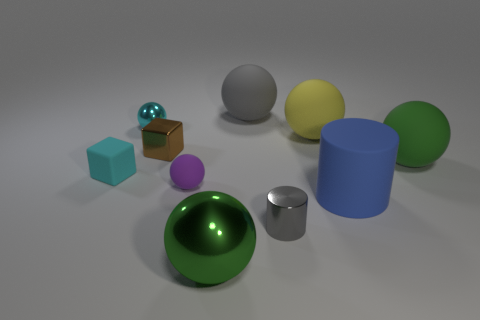What number of objects are matte balls on the right side of the big shiny ball or small red things?
Keep it short and to the point. 3. Is the color of the tiny rubber sphere the same as the metallic sphere that is behind the large green shiny thing?
Give a very brief answer. No. Is there a green rubber ball that has the same size as the purple sphere?
Offer a very short reply. No. What material is the tiny sphere in front of the large green sphere that is behind the green metallic sphere made of?
Make the answer very short. Rubber. What number of small rubber balls are the same color as the small matte block?
Your answer should be compact. 0. What shape is the cyan thing that is made of the same material as the tiny brown cube?
Offer a very short reply. Sphere. There is a metallic ball that is in front of the blue rubber object; how big is it?
Provide a short and direct response. Large. Is the number of cylinders that are behind the cyan metallic object the same as the number of small purple rubber balls that are on the right side of the yellow rubber object?
Give a very brief answer. Yes. What color is the metal sphere that is on the right side of the rubber ball that is in front of the cube left of the small brown cube?
Provide a succinct answer. Green. What number of things are both right of the small cylinder and in front of the large green matte object?
Your answer should be compact. 1. 